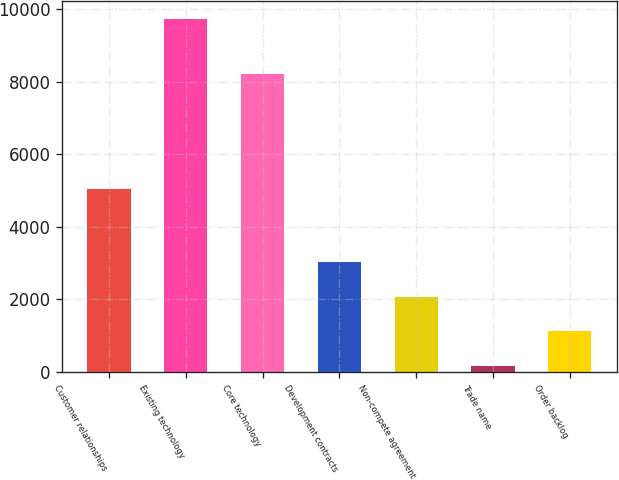<chart> <loc_0><loc_0><loc_500><loc_500><bar_chart><fcel>Customer relationships<fcel>Existing technology<fcel>Core technology<fcel>Development contracts<fcel>Non-compete agreement<fcel>Trade name<fcel>Order backlog<nl><fcel>5050<fcel>9720<fcel>8200<fcel>3028<fcel>2072<fcel>160<fcel>1116<nl></chart> 